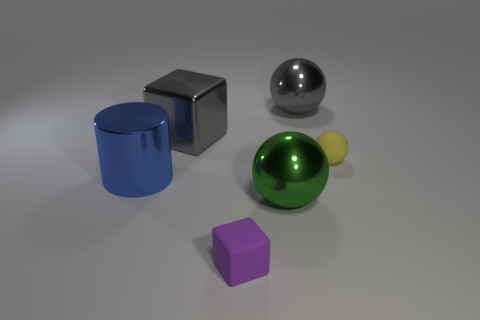There is a yellow thing that is the same material as the small purple cube; what size is it?
Give a very brief answer. Small. What number of big gray objects are the same shape as the tiny yellow matte object?
Give a very brief answer. 1. Is the number of gray shiny things that are in front of the small matte ball greater than the number of metal cylinders right of the green object?
Keep it short and to the point. No. There is a matte cube; is its color the same as the matte object behind the matte block?
Your response must be concise. No. There is a gray ball that is the same size as the blue cylinder; what is its material?
Ensure brevity in your answer.  Metal. What number of objects are either small green cylinders or small things that are behind the blue metallic thing?
Keep it short and to the point. 1. There is a gray block; is its size the same as the matte thing behind the blue cylinder?
Provide a short and direct response. No. What number of cubes are either small matte things or large metal things?
Your answer should be very brief. 2. How many shiny objects are to the left of the large block and right of the small block?
Provide a succinct answer. 0. What number of other things are there of the same color as the small rubber cube?
Your answer should be compact. 0. 